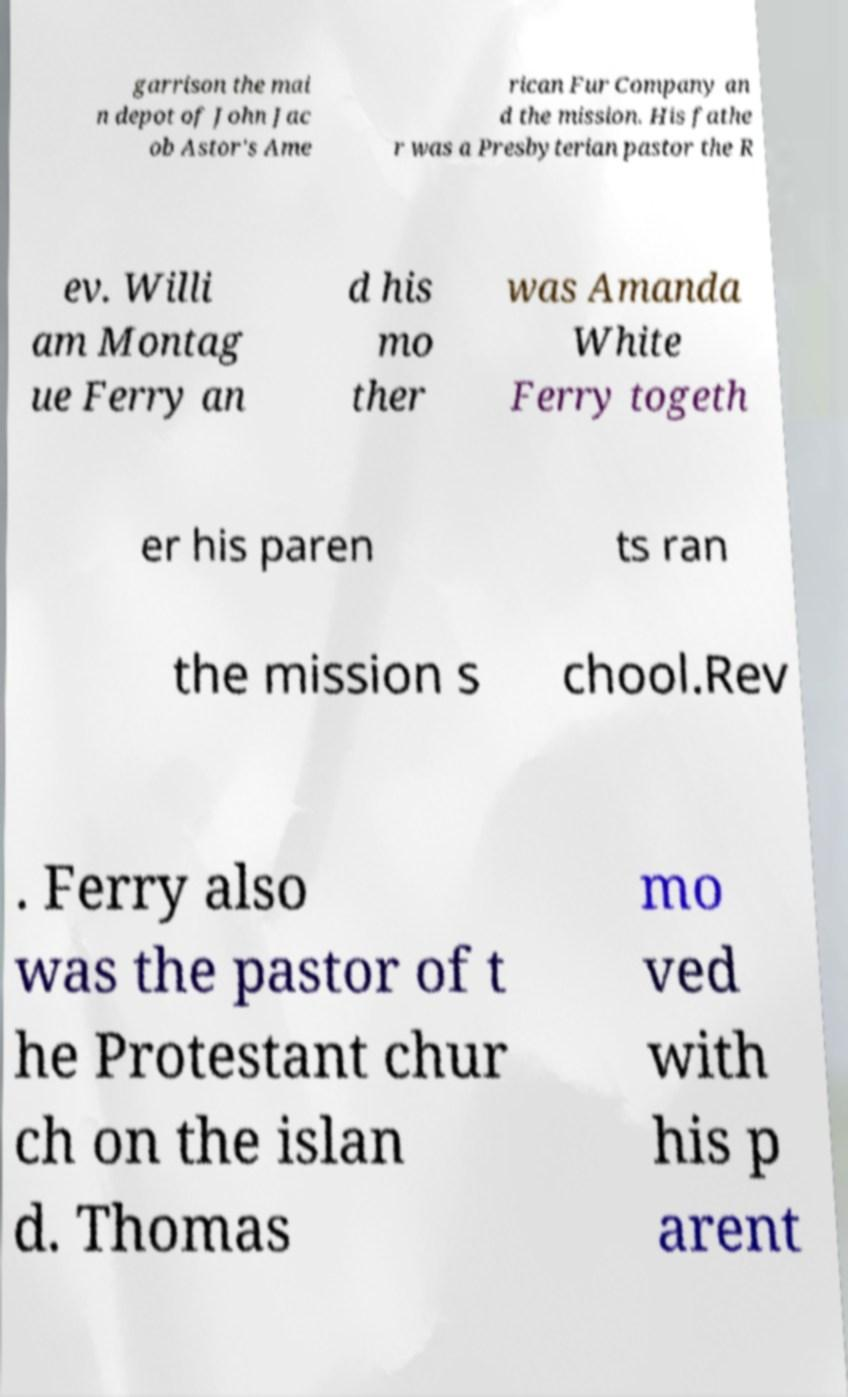Can you accurately transcribe the text from the provided image for me? garrison the mai n depot of John Jac ob Astor's Ame rican Fur Company an d the mission. His fathe r was a Presbyterian pastor the R ev. Willi am Montag ue Ferry an d his mo ther was Amanda White Ferry togeth er his paren ts ran the mission s chool.Rev . Ferry also was the pastor of t he Protestant chur ch on the islan d. Thomas mo ved with his p arent 